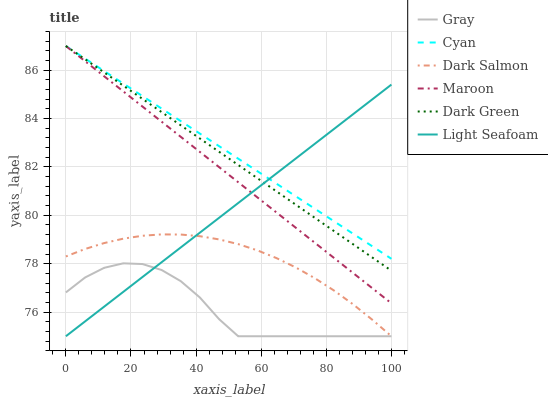Does Gray have the minimum area under the curve?
Answer yes or no. Yes. Does Cyan have the maximum area under the curve?
Answer yes or no. Yes. Does Dark Salmon have the minimum area under the curve?
Answer yes or no. No. Does Dark Salmon have the maximum area under the curve?
Answer yes or no. No. Is Cyan the smoothest?
Answer yes or no. Yes. Is Gray the roughest?
Answer yes or no. Yes. Is Dark Salmon the smoothest?
Answer yes or no. No. Is Dark Salmon the roughest?
Answer yes or no. No. Does Gray have the lowest value?
Answer yes or no. Yes. Does Maroon have the lowest value?
Answer yes or no. No. Does Dark Green have the highest value?
Answer yes or no. Yes. Does Dark Salmon have the highest value?
Answer yes or no. No. Is Gray less than Maroon?
Answer yes or no. Yes. Is Dark Green greater than Gray?
Answer yes or no. Yes. Does Dark Green intersect Light Seafoam?
Answer yes or no. Yes. Is Dark Green less than Light Seafoam?
Answer yes or no. No. Is Dark Green greater than Light Seafoam?
Answer yes or no. No. Does Gray intersect Maroon?
Answer yes or no. No. 